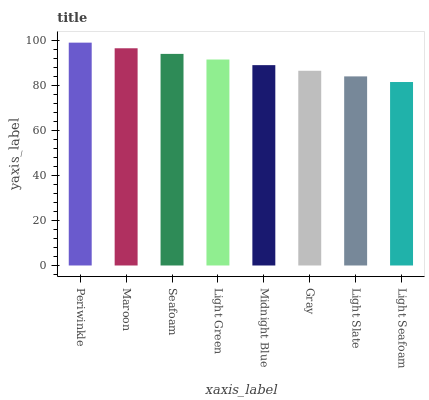Is Light Seafoam the minimum?
Answer yes or no. Yes. Is Periwinkle the maximum?
Answer yes or no. Yes. Is Maroon the minimum?
Answer yes or no. No. Is Maroon the maximum?
Answer yes or no. No. Is Periwinkle greater than Maroon?
Answer yes or no. Yes. Is Maroon less than Periwinkle?
Answer yes or no. Yes. Is Maroon greater than Periwinkle?
Answer yes or no. No. Is Periwinkle less than Maroon?
Answer yes or no. No. Is Light Green the high median?
Answer yes or no. Yes. Is Midnight Blue the low median?
Answer yes or no. Yes. Is Gray the high median?
Answer yes or no. No. Is Periwinkle the low median?
Answer yes or no. No. 